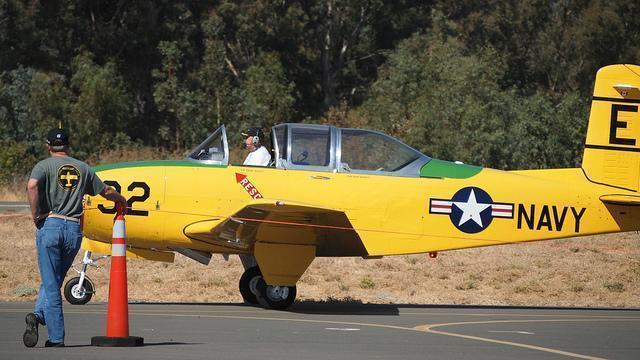Who served in the branch of the military whose name appears on the vehicle?
Indicate the correct response by choosing from the four available options to answer the question.
Options: Sergeant slaughter, captain kidd, lieutenant green, jimmy carter. Jimmy carter. What color is the stripe near the hull of the aircraft?
Answer the question by selecting the correct answer among the 4 following choices.
Options: Green, red, orange, blue. Green. 